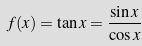<formula> <loc_0><loc_0><loc_500><loc_500>f ( x ) = \tan x = { \frac { \sin x } { \cos x } }</formula> 